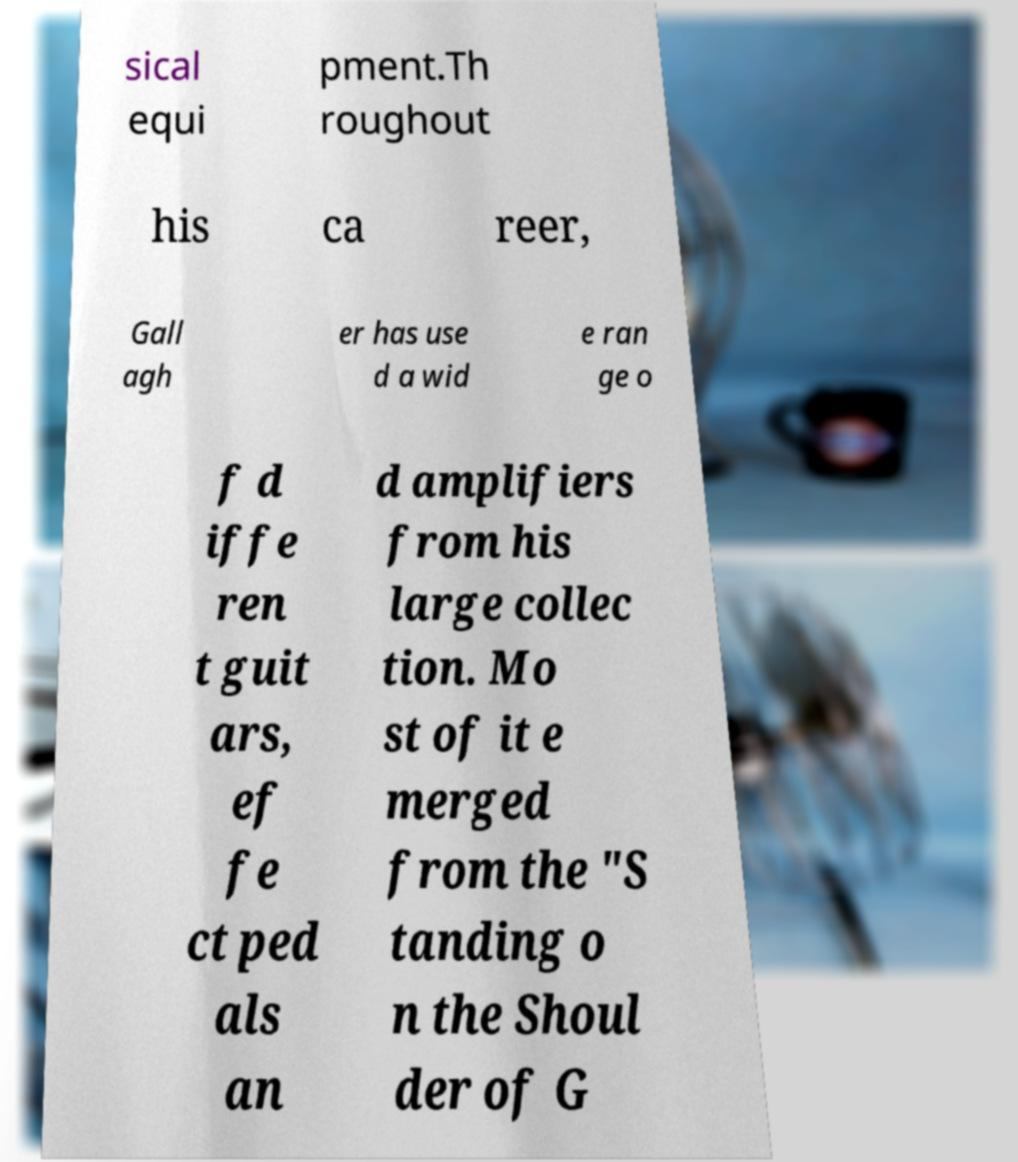Can you read and provide the text displayed in the image?This photo seems to have some interesting text. Can you extract and type it out for me? sical equi pment.Th roughout his ca reer, Gall agh er has use d a wid e ran ge o f d iffe ren t guit ars, ef fe ct ped als an d amplifiers from his large collec tion. Mo st of it e merged from the "S tanding o n the Shoul der of G 